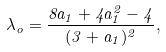Convert formula to latex. <formula><loc_0><loc_0><loc_500><loc_500>\lambda _ { o } = \frac { 8 a _ { 1 } + 4 a _ { 1 } ^ { 2 } - 4 } { ( 3 + a _ { 1 } ) ^ { 2 } } ,</formula> 